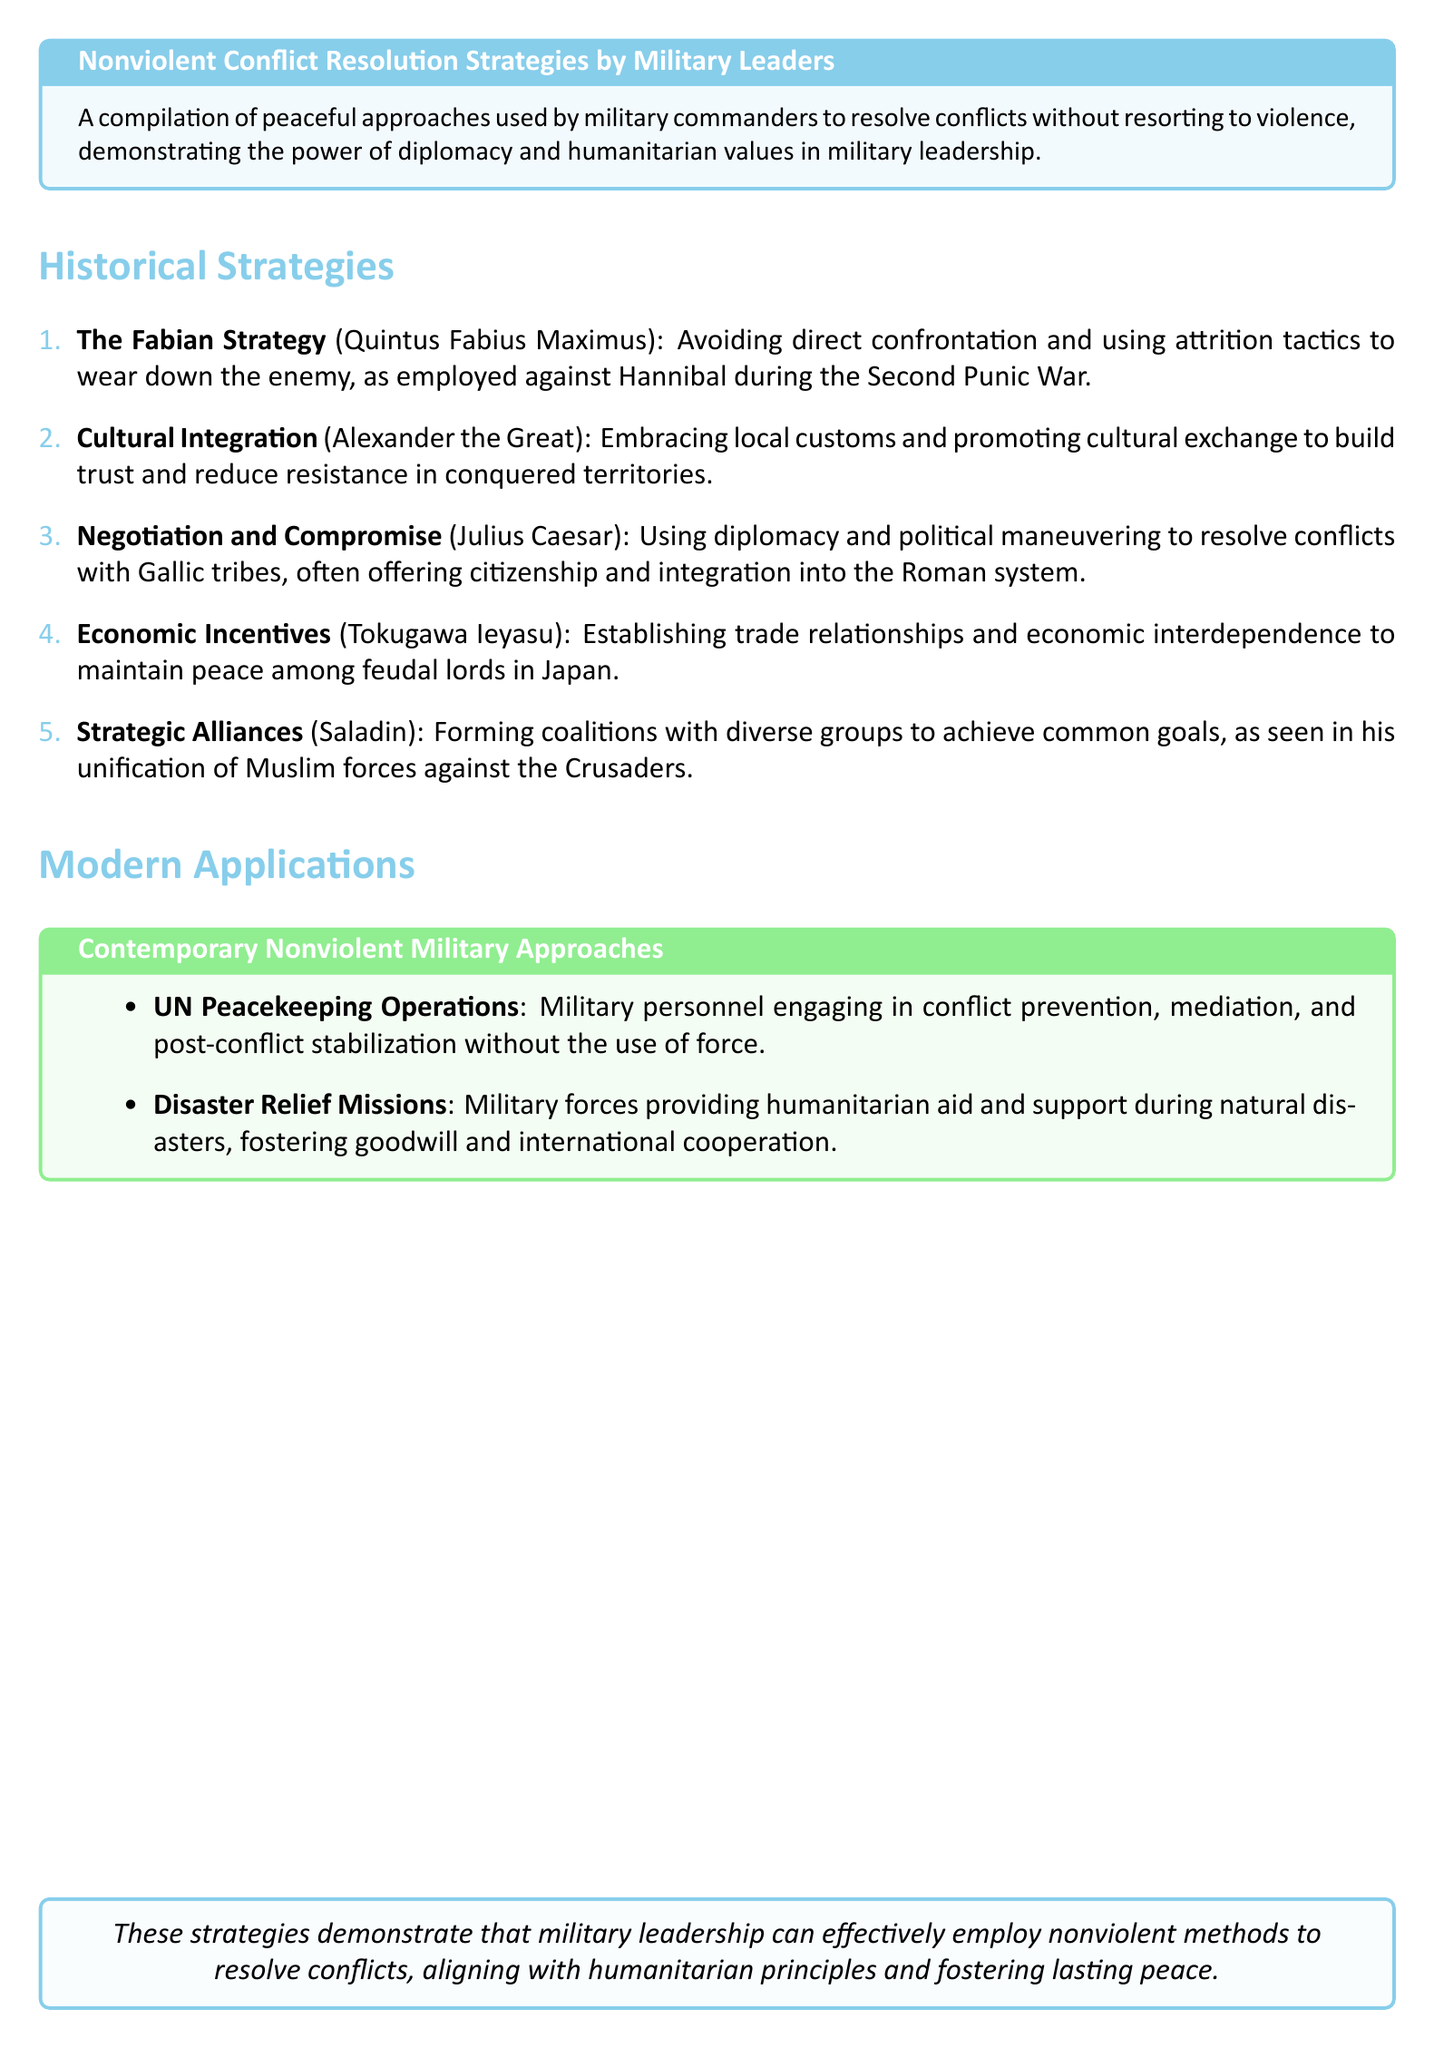What is the name of the strategy used by Quintus Fabius Maximus? The document refers to this as "The Fabian Strategy."
Answer: The Fabian Strategy Who promoted cultural integration during military campaigns? The document states that this was done by "Alexander the Great."
Answer: Alexander the Great Which leader utilized negotiation and compromise with the Gallic tribes? The document identifies this leader as "Julius Caesar."
Answer: Julius Caesar What strategy did Tokugawa Ieyasu use to maintain peace in Japan? The document mentions "Economic Incentives."
Answer: Economic Incentives What is one application of modern nonviolent military approaches? The document lists "UN Peacekeeping Operations" as an example.
Answer: UN Peacekeeping Operations How did Saladin achieve common goals among diverse groups? The document states he formed "Strategic Alliances."
Answer: Strategic Alliances What is the overall theme of the document? The document notes the theme is about the effectiveness of nonviolent methods in military leadership.
Answer: Nonviolent methods What color represents the historical strategies section? The document describes the color for this section as "peaceful blue."
Answer: peaceful blue What type of operations are included in contemporary nonviolent military approaches? The document includes "Disaster Relief Missions" as an example.
Answer: Disaster Relief Missions 